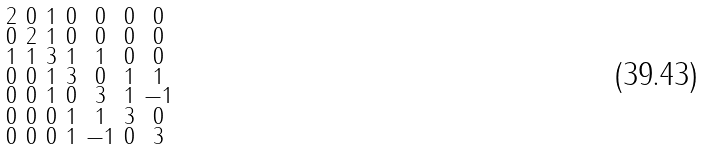Convert formula to latex. <formula><loc_0><loc_0><loc_500><loc_500>\begin{smallmatrix} 2 & 0 & 1 & 0 & 0 & 0 & 0 \\ 0 & 2 & 1 & 0 & 0 & 0 & 0 \\ 1 & 1 & 3 & 1 & 1 & 0 & 0 \\ 0 & 0 & 1 & 3 & 0 & 1 & 1 \\ 0 & 0 & 1 & 0 & 3 & 1 & - 1 \\ 0 & 0 & 0 & 1 & 1 & 3 & 0 \\ 0 & 0 & 0 & 1 & - 1 & 0 & 3 \end{smallmatrix}</formula> 